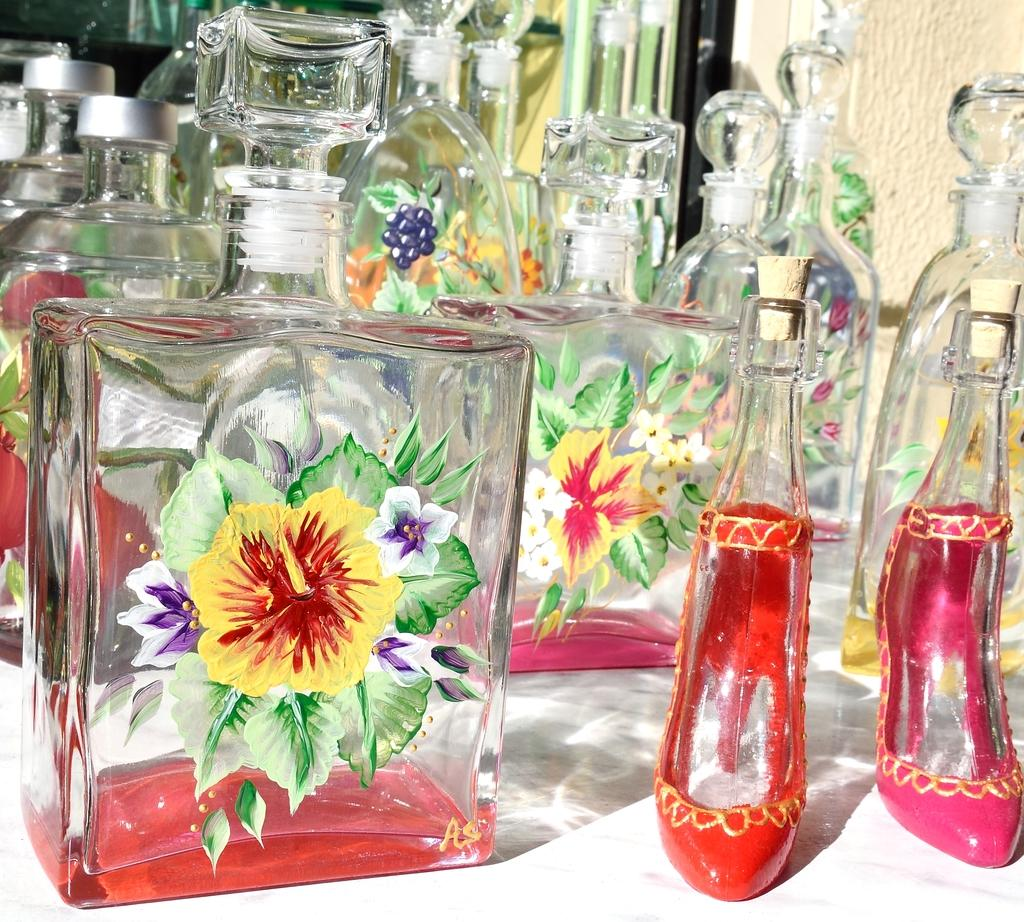What objects are present in the image? There are perfume bottles in the image. Can you describe the perfume bottles in the image? The perfume bottles are of different types. Where are the perfume bottles located in the image? The perfume bottles are on a table. What type of lace can be seen on the perfume bottles in the image? There is no lace present on the perfume bottles in the image. Is there a recess in the table where the perfume bottles are located? The provided facts do not mention any recess in the table where the perfume bottles are located. 